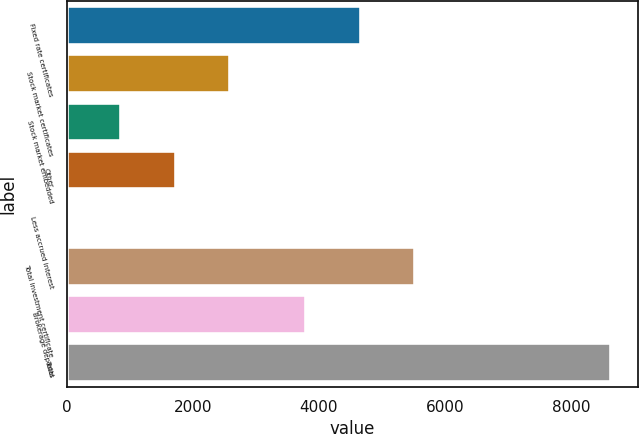Convert chart. <chart><loc_0><loc_0><loc_500><loc_500><bar_chart><fcel>Fixed rate certificates<fcel>Stock market certificates<fcel>Stock market embedded<fcel>Other<fcel>Less accrued interest<fcel>Total investment certificate<fcel>Brokerage deposits<fcel>Total<nl><fcel>4665.1<fcel>2592.3<fcel>866.1<fcel>1729.2<fcel>3<fcel>5528.2<fcel>3802<fcel>8634<nl></chart> 